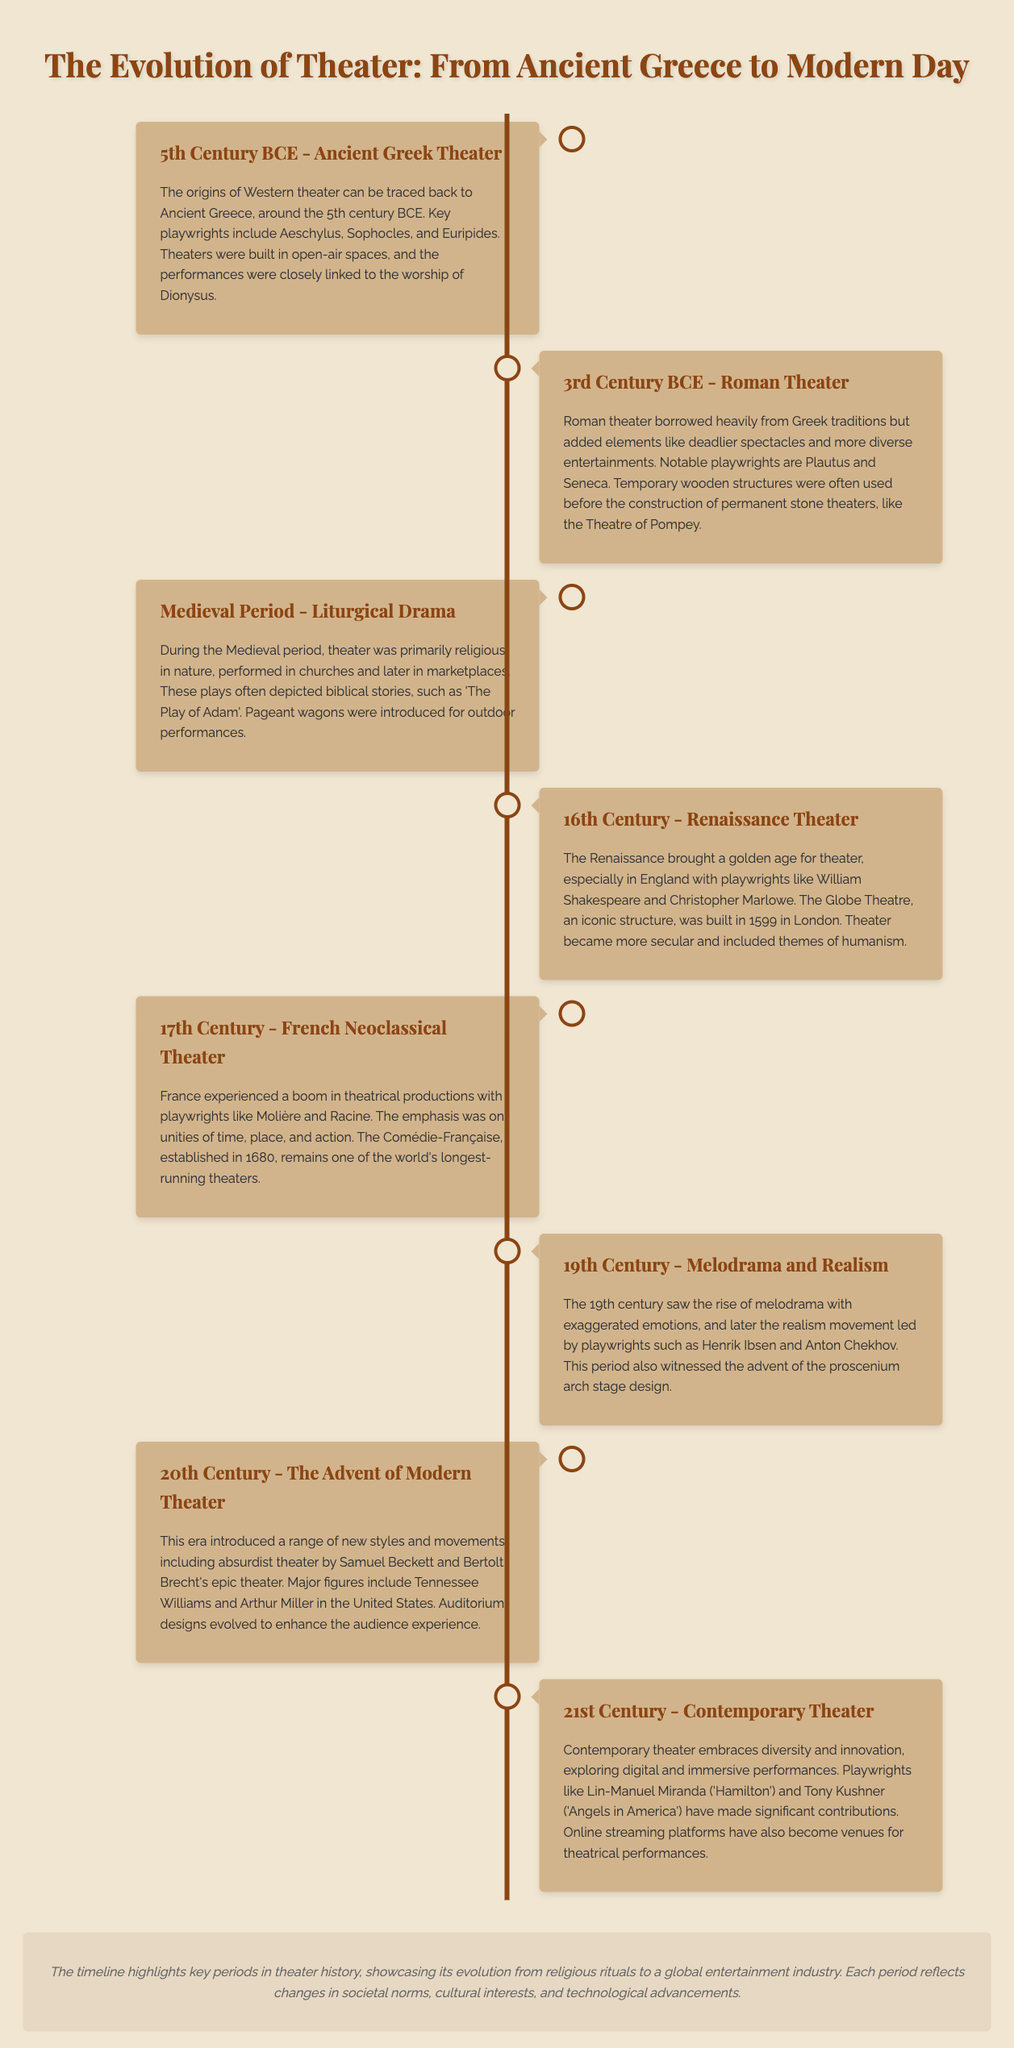What century did Ancient Greek Theater originate? The document states that Ancient Greek Theater originated around the 5th century BCE.
Answer: 5th Century BCE Who are two notable playwrights from the Roman Theater? The Roman Theater section mentions notable playwrights are Plautus and Seneca.
Answer: Plautus and Seneca What type of drama was primarily performed during the Medieval Period? The Medieval Period section indicates that theater was primarily religious in nature.
Answer: Religious Which iconic theater was built in 1599? The Renaissance Theater section mentions the Globe Theatre was built in 1599 in London.
Answer: Globe Theatre What was emphasized in French Neoclassical Theater? The document states that the emphasis was on unities of time, place, and action.
Answer: Unities of time, place, and action What significant stage design emerged in the 19th century? The 19th Century section describes the advent of the proscenium arch stage design.
Answer: Proscenium arch Which playwright is associated with absurdist theater? The document highlights Samuel Beckett as a key figure in absurdist theater during the 20th century.
Answer: Samuel Beckett What modern innovation is explored in 21st-century theater? The Contemporary Theater section mentions digital and immersive performances as a modern innovation.
Answer: Digital and immersive performances How did the theater evolve in its relationship with society? The bottom note states that the timeline showcases the evolution from religious rituals to a global entertainment industry.
Answer: Global entertainment industry 